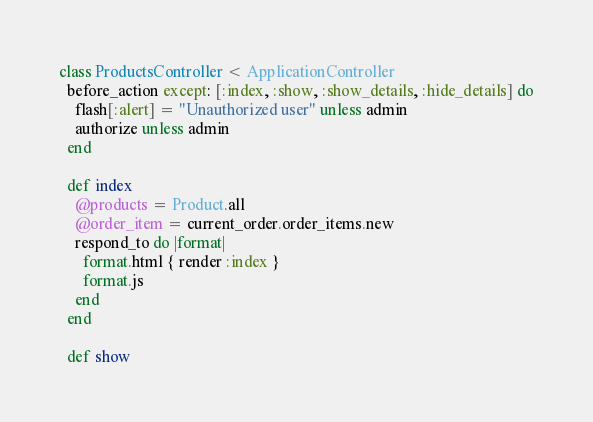<code> <loc_0><loc_0><loc_500><loc_500><_Ruby_>class ProductsController < ApplicationController
  before_action except: [:index, :show, :show_details, :hide_details] do
    flash[:alert] = "Unauthorized user" unless admin
    authorize unless admin
  end

  def index
    @products = Product.all
    @order_item = current_order.order_items.new
    respond_to do |format|
      format.html { render :index }
      format.js 
    end
  end

  def show</code> 